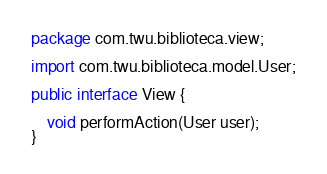<code> <loc_0><loc_0><loc_500><loc_500><_Java_>package com.twu.biblioteca.view;

import com.twu.biblioteca.model.User;

public interface View {

    void performAction(User user);
}</code> 